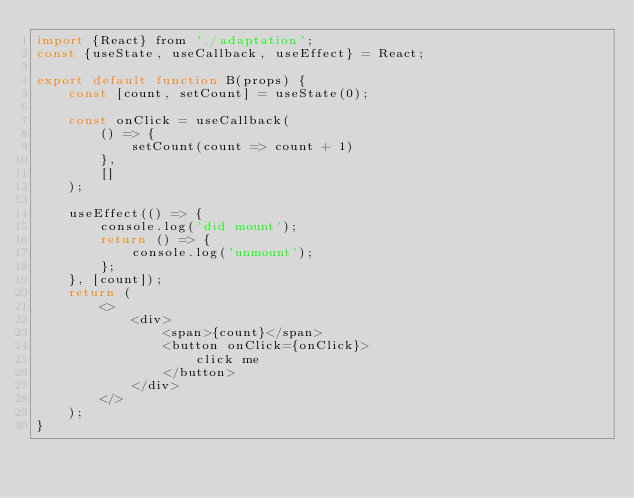Convert code to text. <code><loc_0><loc_0><loc_500><loc_500><_JavaScript_>import {React} from './adaptation';
const {useState, useCallback, useEffect} = React;

export default function B(props) {
    const [count, setCount] = useState(0);

    const onClick = useCallback(
        () => {
            setCount(count => count + 1)
        },
        []
    );

    useEffect(() => {
        console.log('did mount');
        return () => {
            console.log('unmount');
        };
    }, [count]);
    return (
        <>
            <div>
                <span>{count}</span>
                <button onClick={onClick}>
                    click me
                </button>
            </div>
        </>
    );
}</code> 